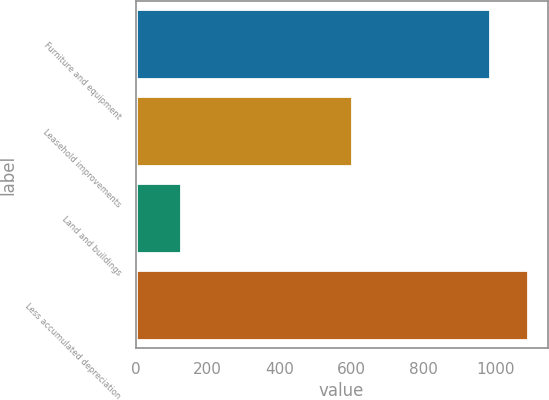<chart> <loc_0><loc_0><loc_500><loc_500><bar_chart><fcel>Furniture and equipment<fcel>Leasehold improvements<fcel>Land and buildings<fcel>Less accumulated depreciation<nl><fcel>983.2<fcel>599.7<fcel>126.1<fcel>1089<nl></chart> 